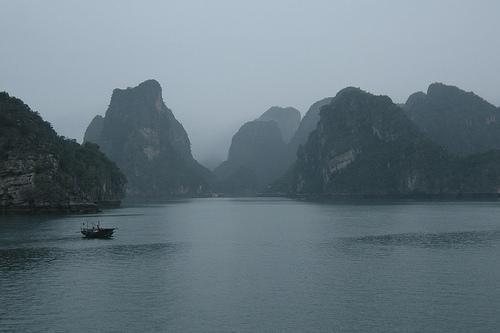How many boats are on the water?
Give a very brief answer. 1. 